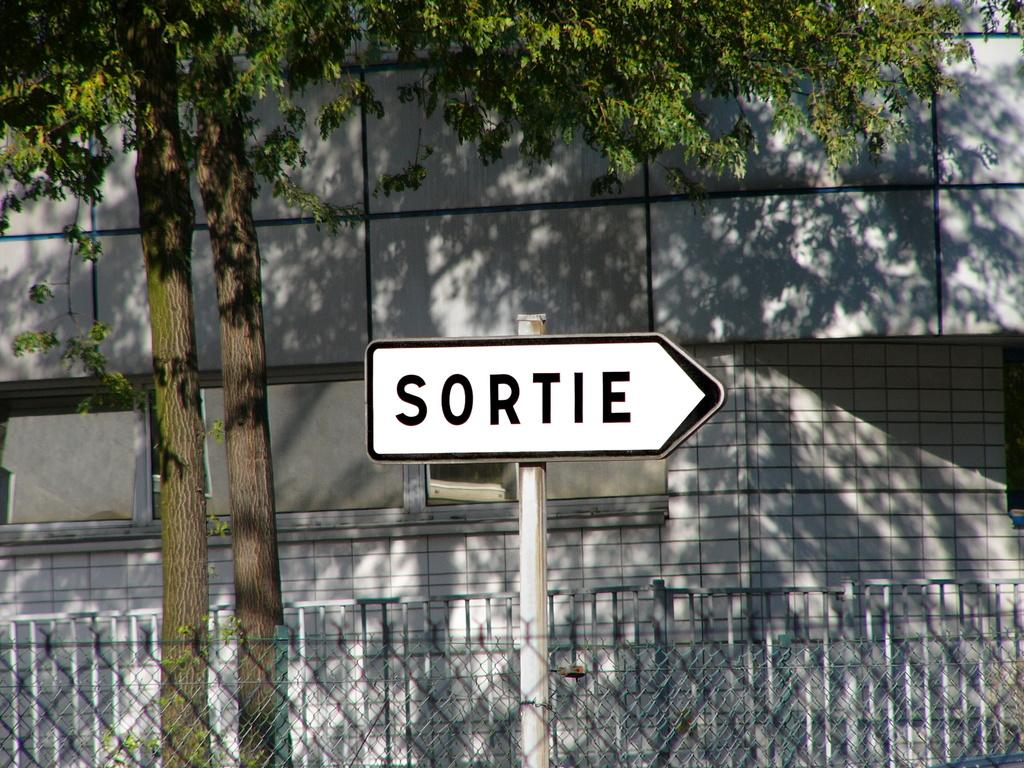What is the main object in the image? There is a directional board in the image. What can be seen in the background of the image? There is fencing, trees, and a building visible in the background of the image. What grade of goat is present in the image? There are no goats present in the image, so it is not possible to determine the grade of any goat. 